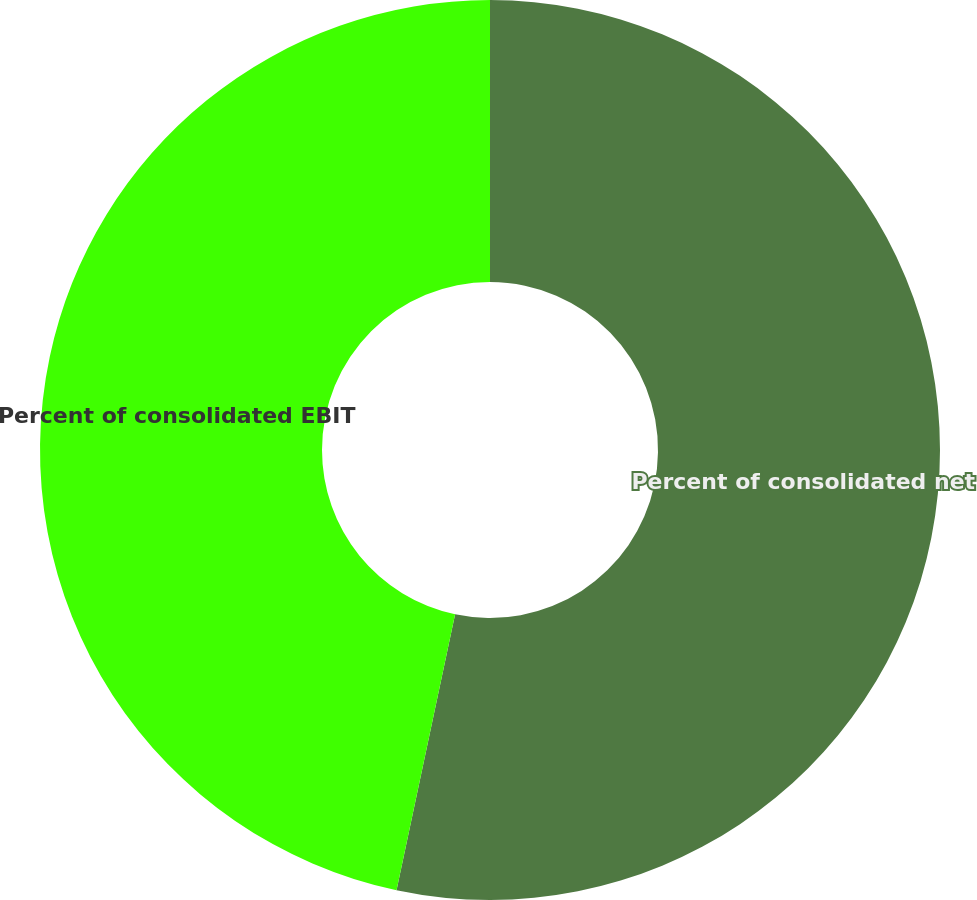Convert chart. <chart><loc_0><loc_0><loc_500><loc_500><pie_chart><fcel>Percent of consolidated net<fcel>Percent of consolidated EBIT<nl><fcel>53.33%<fcel>46.67%<nl></chart> 